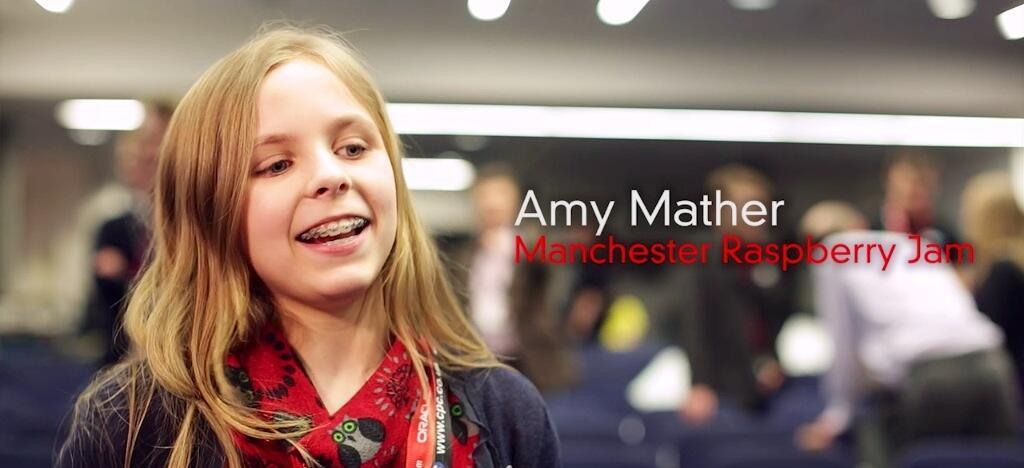What is the main feature in the center of the image? There is some text in the center of the image. Can you describe the woman in the image? There is a woman in the image, and she is smiling. How would you describe the background of the image? The background of the image is blurred. What type of plant is growing in the center of the image? There is no plant present in the image; the main feature is text. 